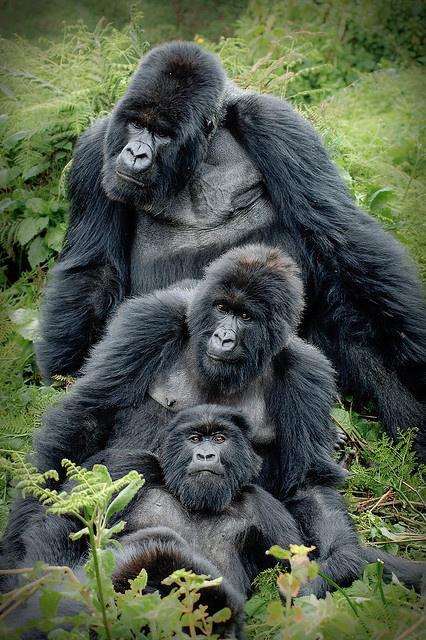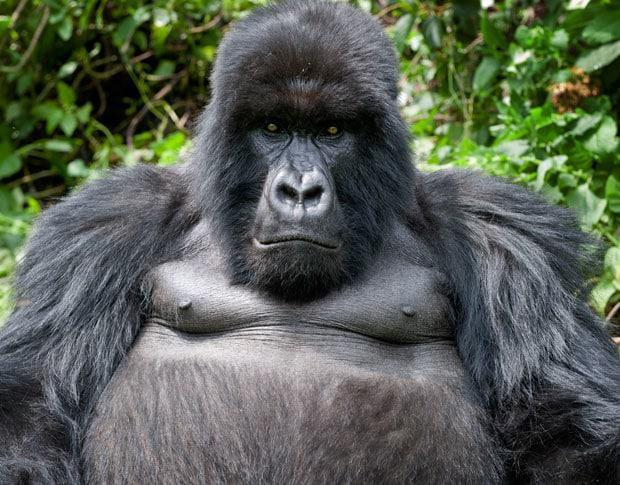The first image is the image on the left, the second image is the image on the right. Considering the images on both sides, is "One image shows an adult gorilla with two infant gorillas held to its chest." valid? Answer yes or no. No. The first image is the image on the left, the second image is the image on the right. Evaluate the accuracy of this statement regarding the images: "An adult primate holds two of its young close to its chest in the image on the left.". Is it true? Answer yes or no. No. 